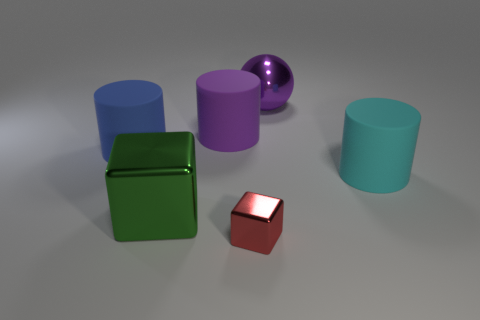What number of small objects have the same shape as the large blue rubber object?
Ensure brevity in your answer.  0. There is a big purple object that is in front of the large shiny object right of the purple cylinder; what is its shape?
Offer a terse response. Cylinder. Is the size of the shiny thing behind the blue cylinder the same as the large cyan cylinder?
Give a very brief answer. Yes. There is a metallic object that is both behind the red metal object and in front of the large purple ball; what size is it?
Provide a short and direct response. Large. What number of green cubes have the same size as the purple cylinder?
Your answer should be compact. 1. There is a rubber cylinder right of the purple metal sphere; what number of purple cylinders are left of it?
Your answer should be compact. 1. Do the large metal thing that is behind the big cyan cylinder and the large metal block have the same color?
Make the answer very short. No. There is a rubber cylinder that is on the right side of the shiny thing behind the purple matte cylinder; is there a cyan rubber cylinder in front of it?
Your response must be concise. No. The large object that is behind the large green cube and to the left of the purple rubber object has what shape?
Your answer should be very brief. Cylinder. Are there any small shiny blocks of the same color as the small thing?
Make the answer very short. No. 